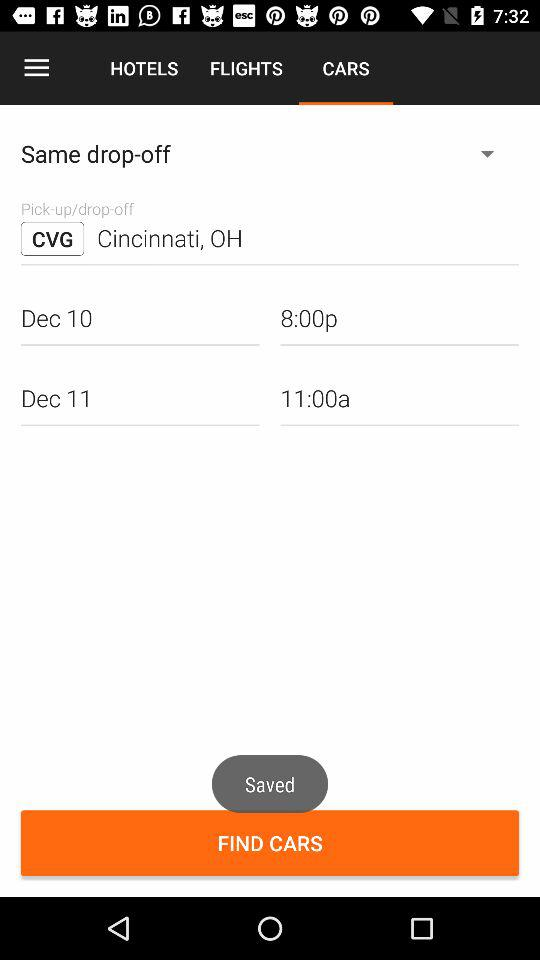Which tab am I using? You are using the tab "CARS". 